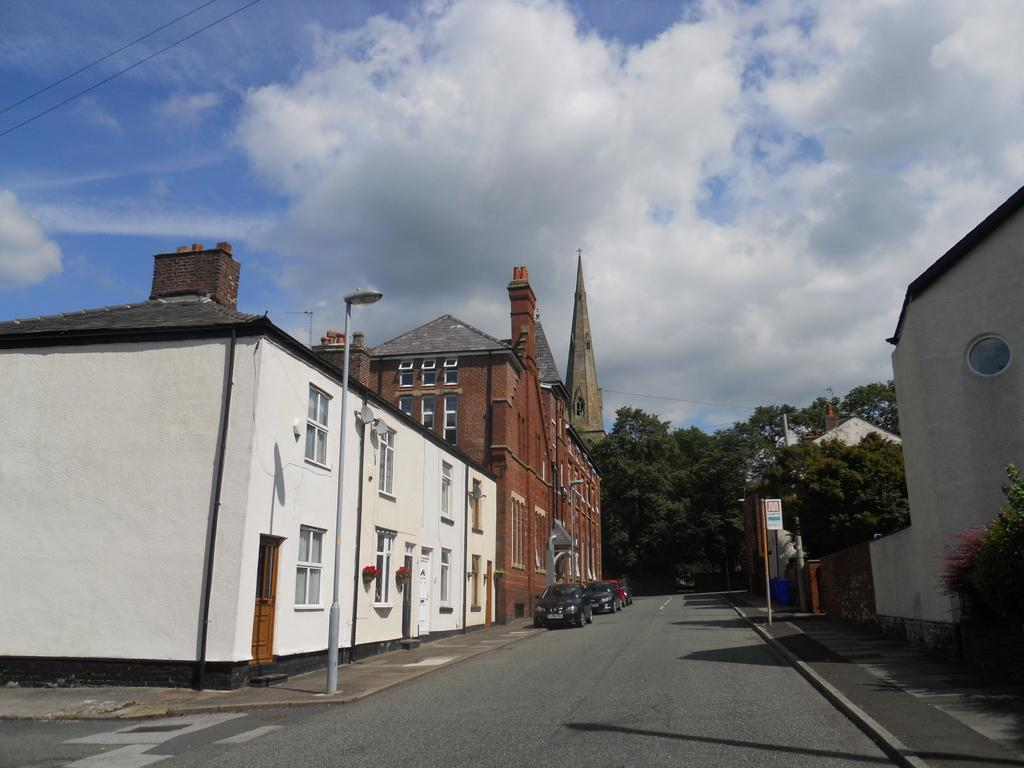What type of structures can be seen in the image? There are buildings in the image. What can be seen illuminating the road in the image? Street lights are present in the image. What type of vegetation is visible in the image? Trees are visible in the image. What type of transportation is on the road in the image? Vehicles are on the road in the image. What is visible at the top of the image? The sky is visible at the top of the image. Can you determine the time of day from the image? The image appears to be taken during the day. Where is the chess club located in the image? There is no chess club present in the image. What type of point is being made by the street lights in the image? Street lights do not make points; they provide illumination for the road. 